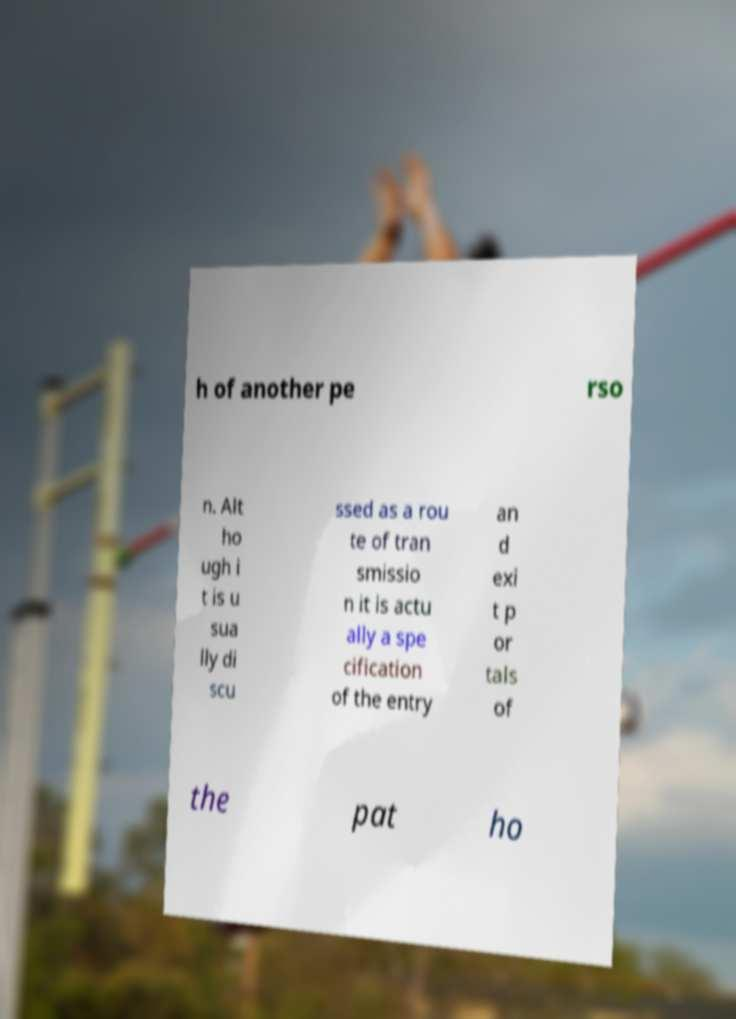Please read and relay the text visible in this image. What does it say? h of another pe rso n. Alt ho ugh i t is u sua lly di scu ssed as a rou te of tran smissio n it is actu ally a spe cification of the entry an d exi t p or tals of the pat ho 